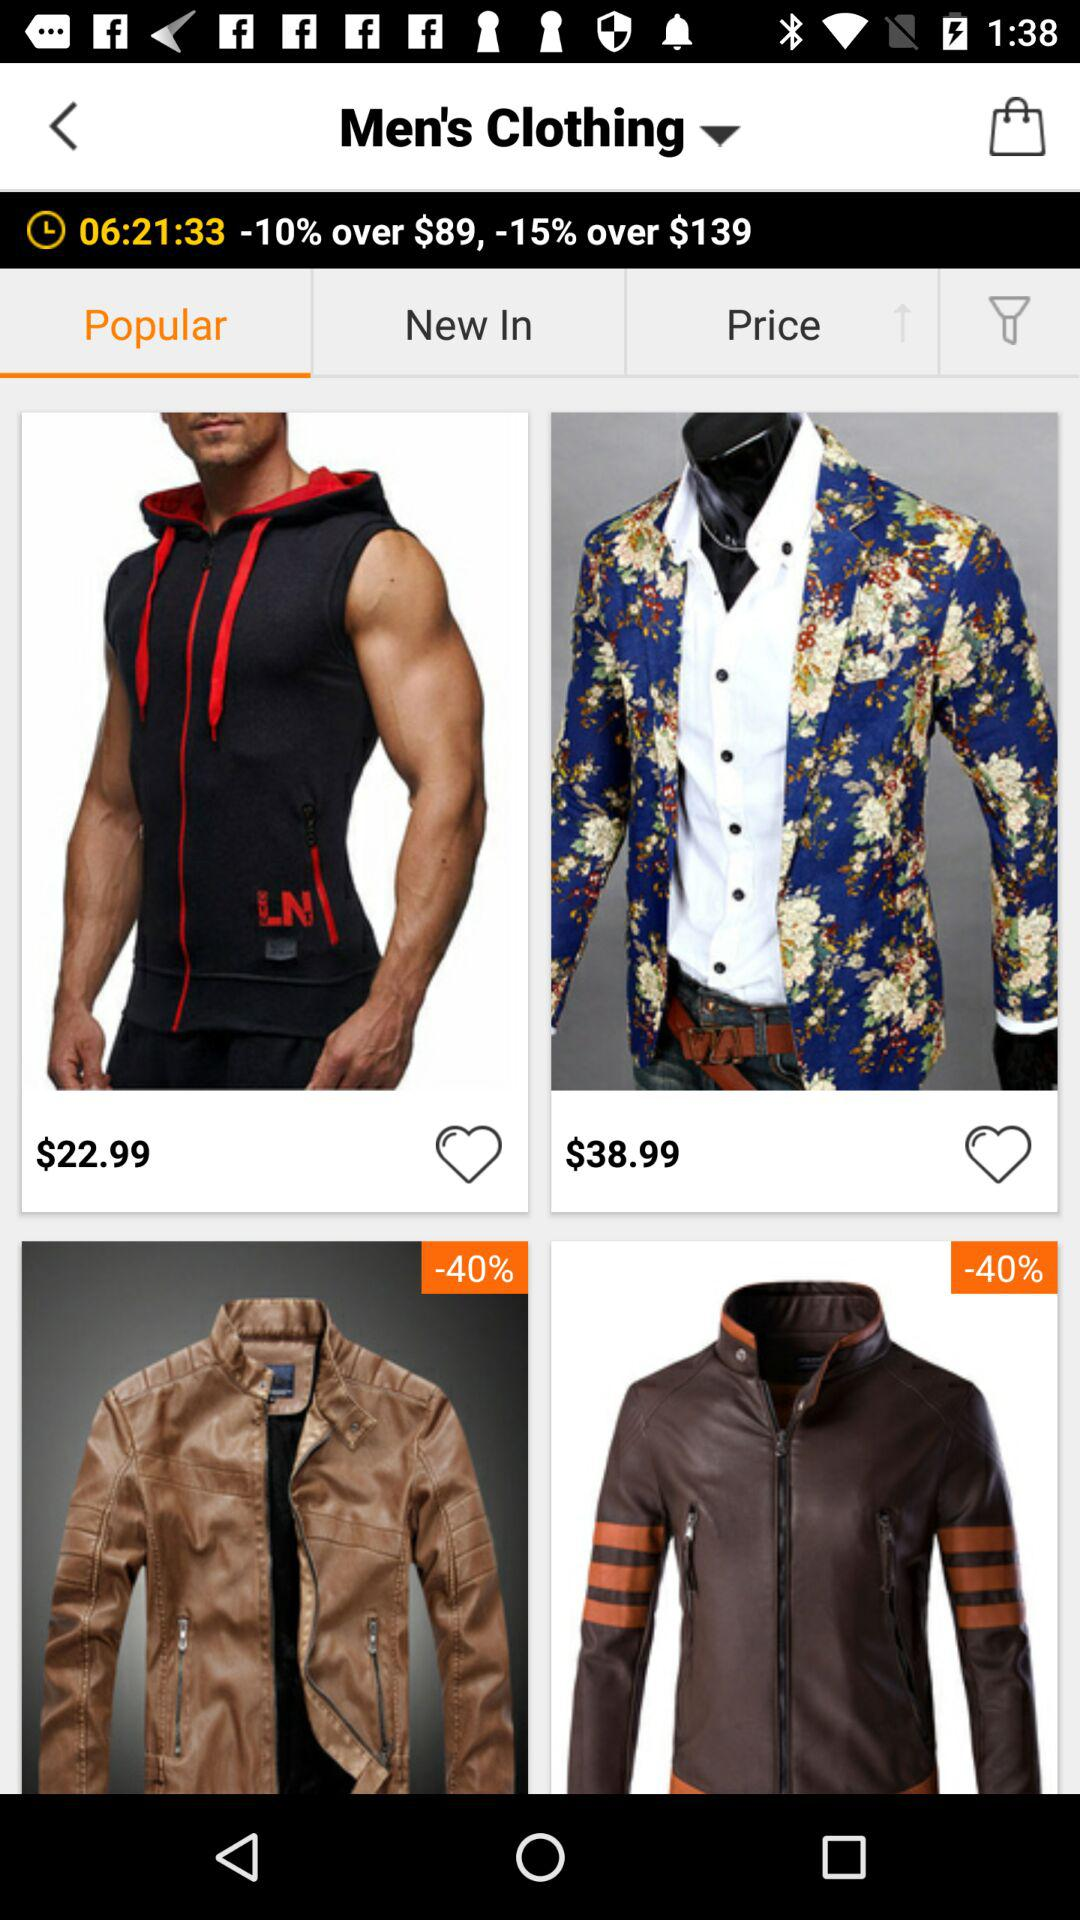What is the price of half sleeve hoodies?
When the provided information is insufficient, respond with <no answer>. <no answer> 